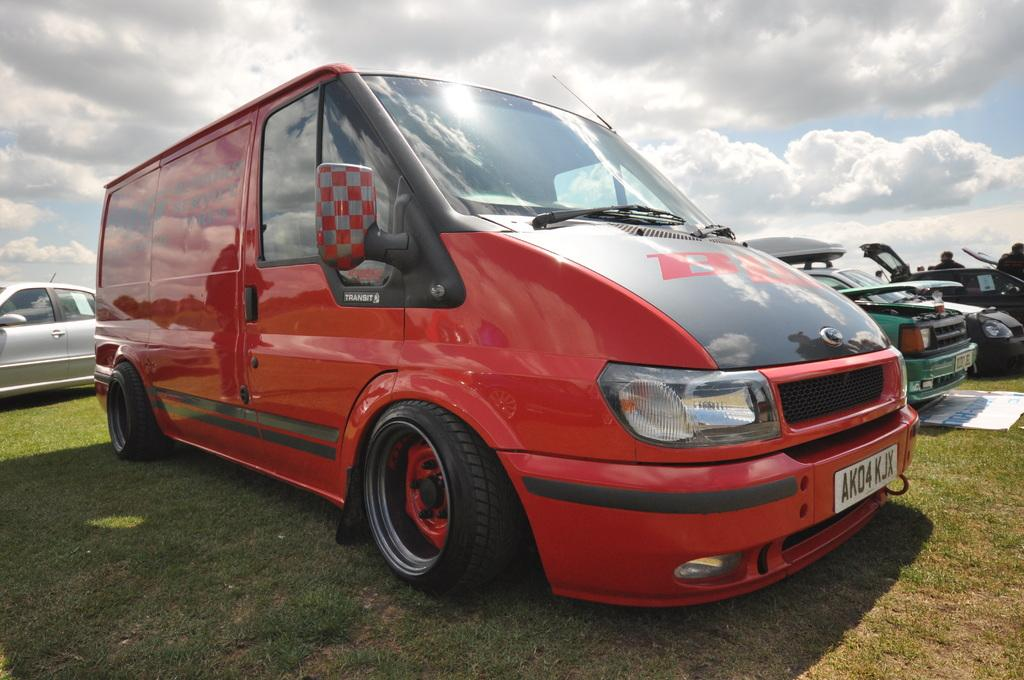What types of objects are on the ground in the image? There are vehicles on the ground in the image. What type of vegetation is present on the ground in the image? There is grass on the ground in the image. What can be seen in the sky in the image? There are clouds visible in the sky in the image. Where is the plate located in the image? There is no plate present in the image. What type of glove is being worn by the person in the image? There is no person or glove present in the image. 